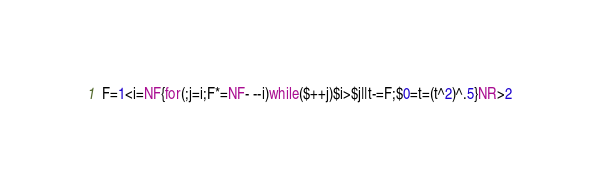Convert code to text. <code><loc_0><loc_0><loc_500><loc_500><_Awk_>F=1<i=NF{for(;j=i;F*=NF- --i)while($++j)$i>$j||t-=F;$0=t=(t^2)^.5}NR>2</code> 